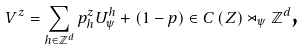<formula> <loc_0><loc_0><loc_500><loc_500>V ^ { z } = \sum _ { h \in \mathbb { Z } ^ { d } } p _ { h } ^ { z } U _ { \psi } ^ { h } + \left ( 1 - p \right ) \in C \left ( Z \right ) \rtimes _ { \psi } \mathbb { Z } ^ { d } \text {,}</formula> 